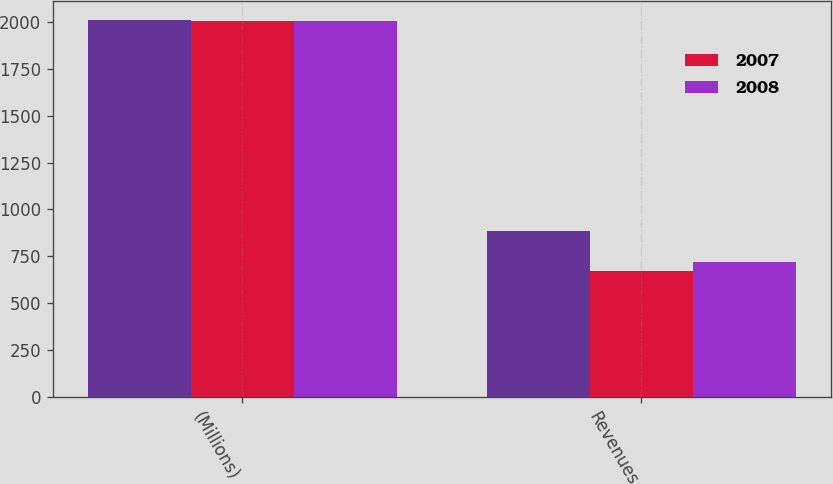Convert chart to OTSL. <chart><loc_0><loc_0><loc_500><loc_500><stacked_bar_chart><ecel><fcel>(Millions)<fcel>Revenues<nl><fcel>nan<fcel>2008<fcel>885<nl><fcel>2007<fcel>2007<fcel>674<nl><fcel>2008<fcel>2006<fcel>721<nl></chart> 